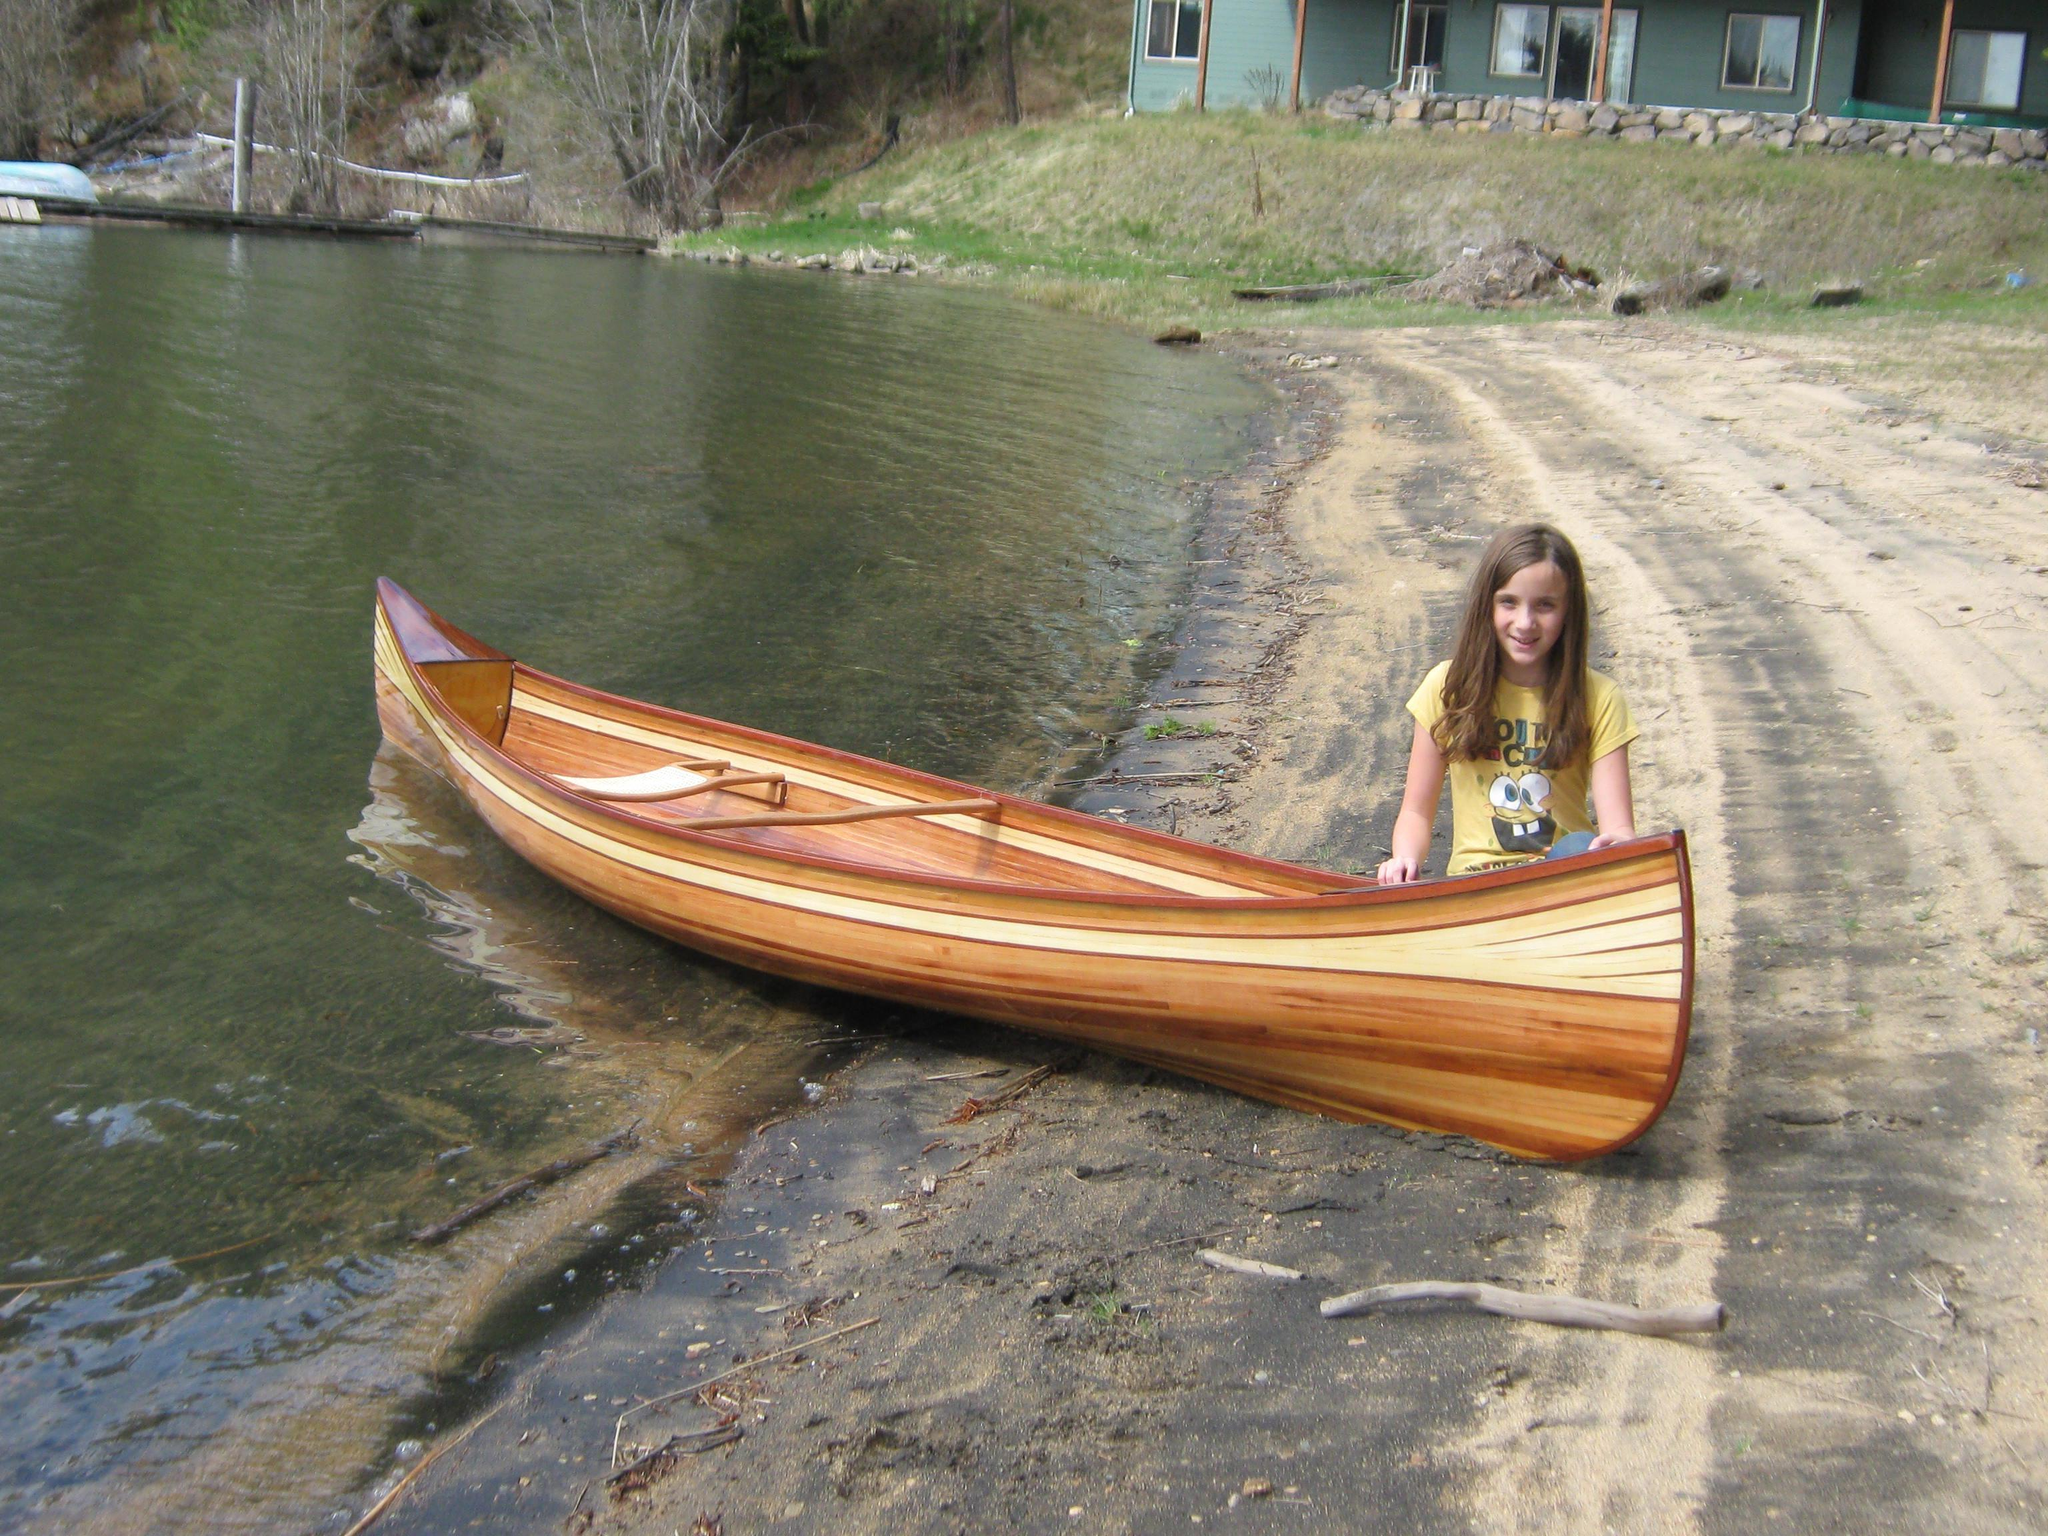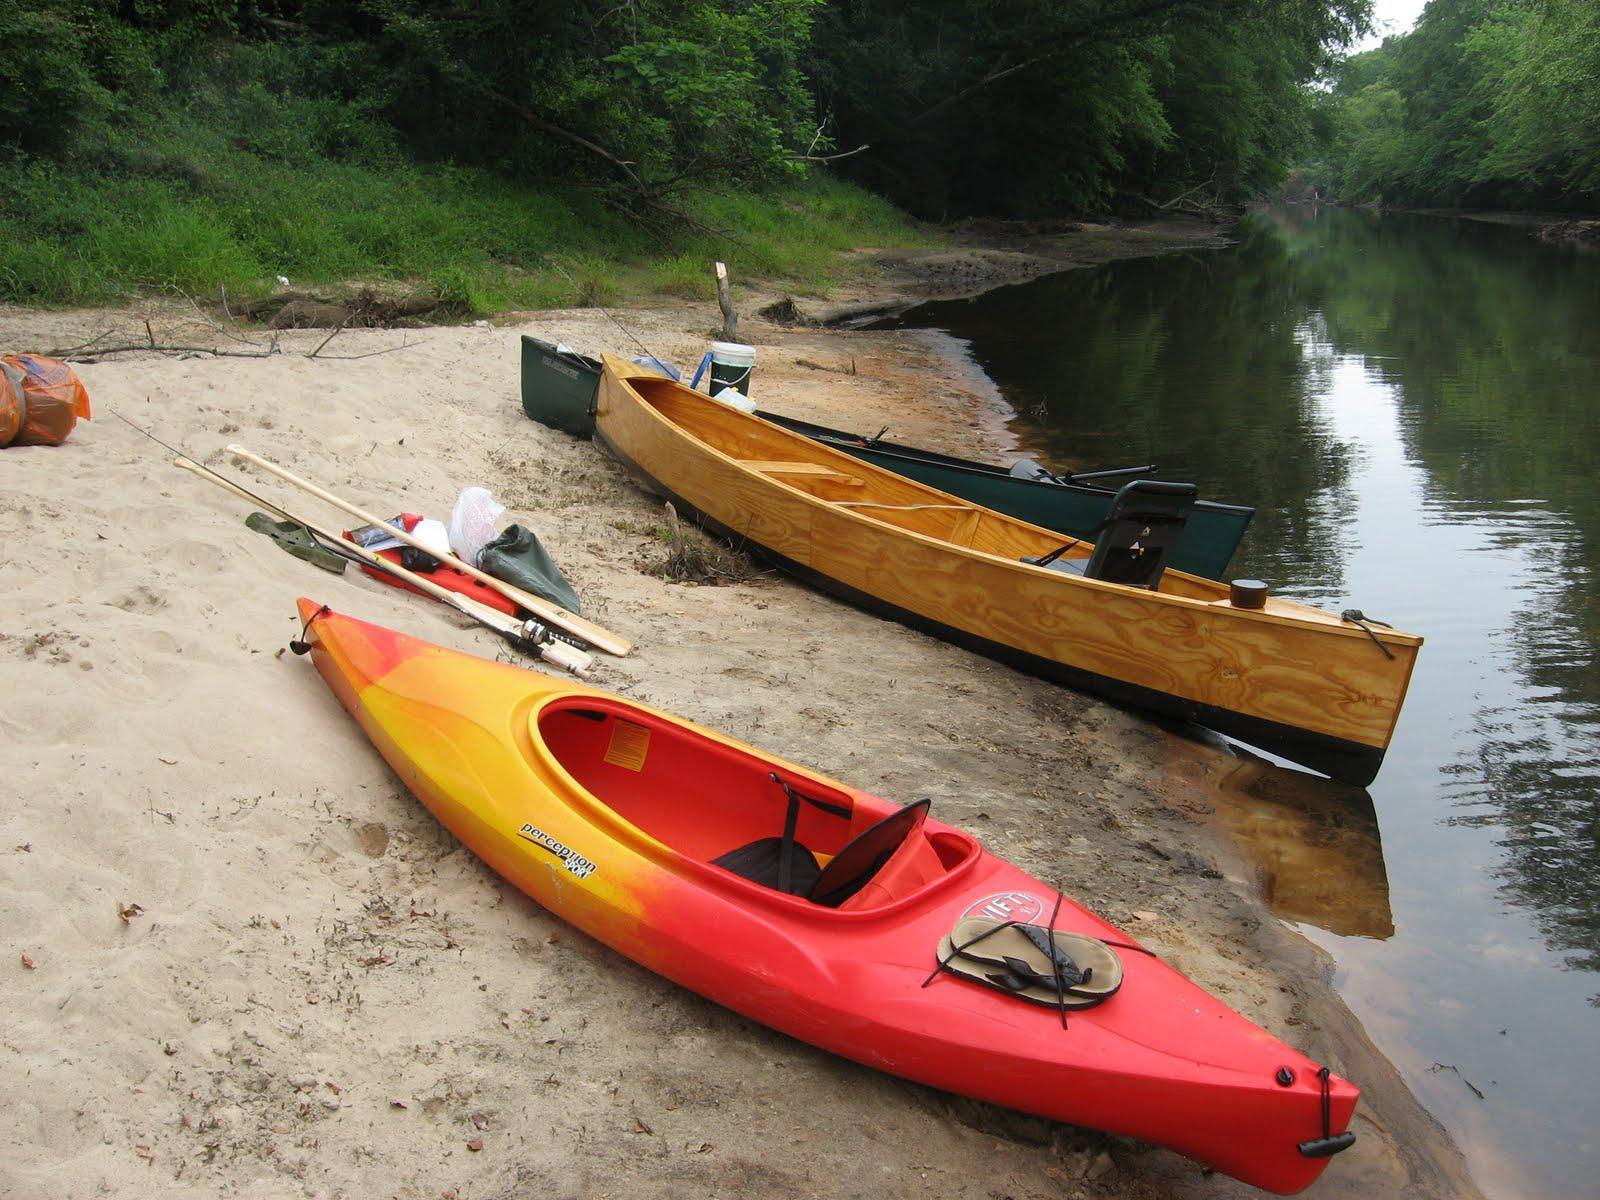The first image is the image on the left, the second image is the image on the right. For the images shown, is this caption "At least one boat is partially on land and partially in water." true? Answer yes or no. Yes. The first image is the image on the left, the second image is the image on the right. Analyze the images presented: Is the assertion "One image shows a brown canoe floating on water, and the other image shows one canoe sitting on dry ground with no water in sight." valid? Answer yes or no. No. 